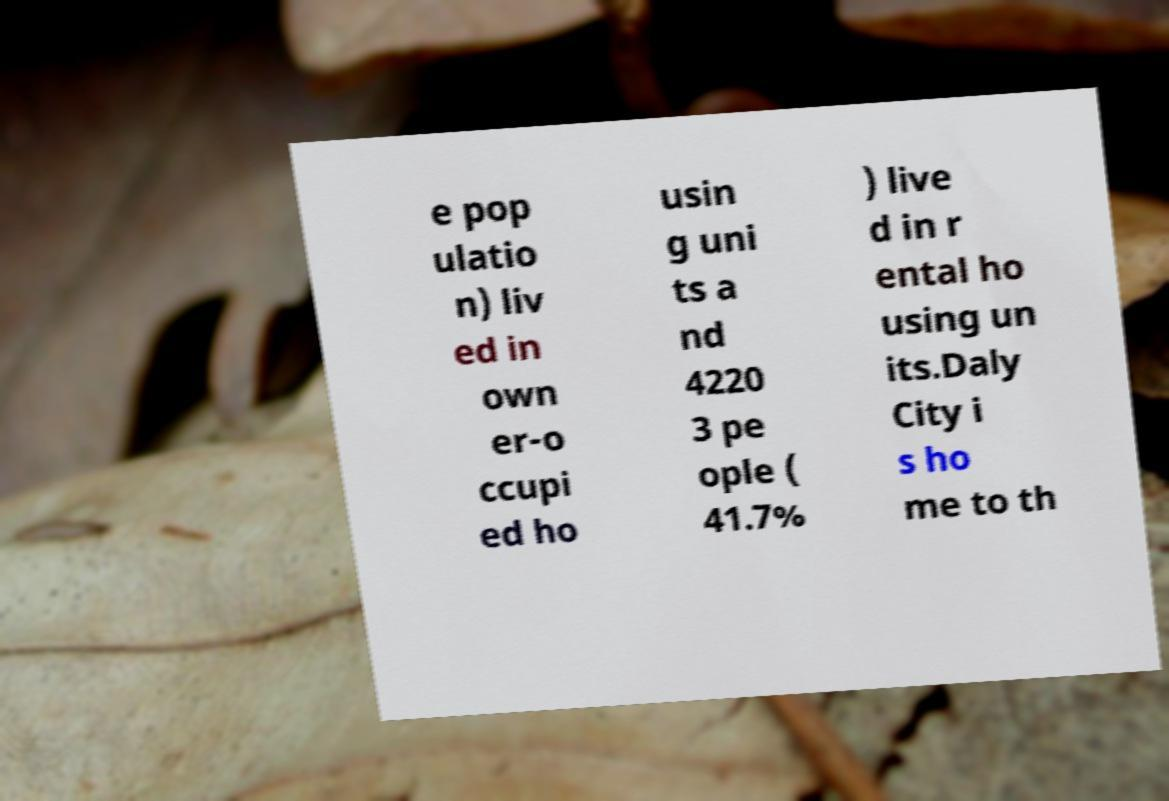Could you extract and type out the text from this image? e pop ulatio n) liv ed in own er-o ccupi ed ho usin g uni ts a nd 4220 3 pe ople ( 41.7% ) live d in r ental ho using un its.Daly City i s ho me to th 